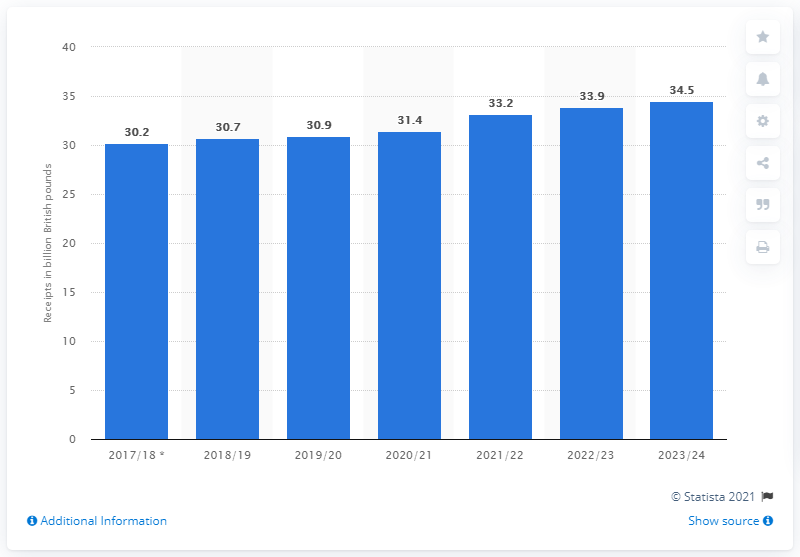Specify some key components in this picture. It is forecasted that business rates will generate 30.9 billion pounds in revenue in 2018/19. 